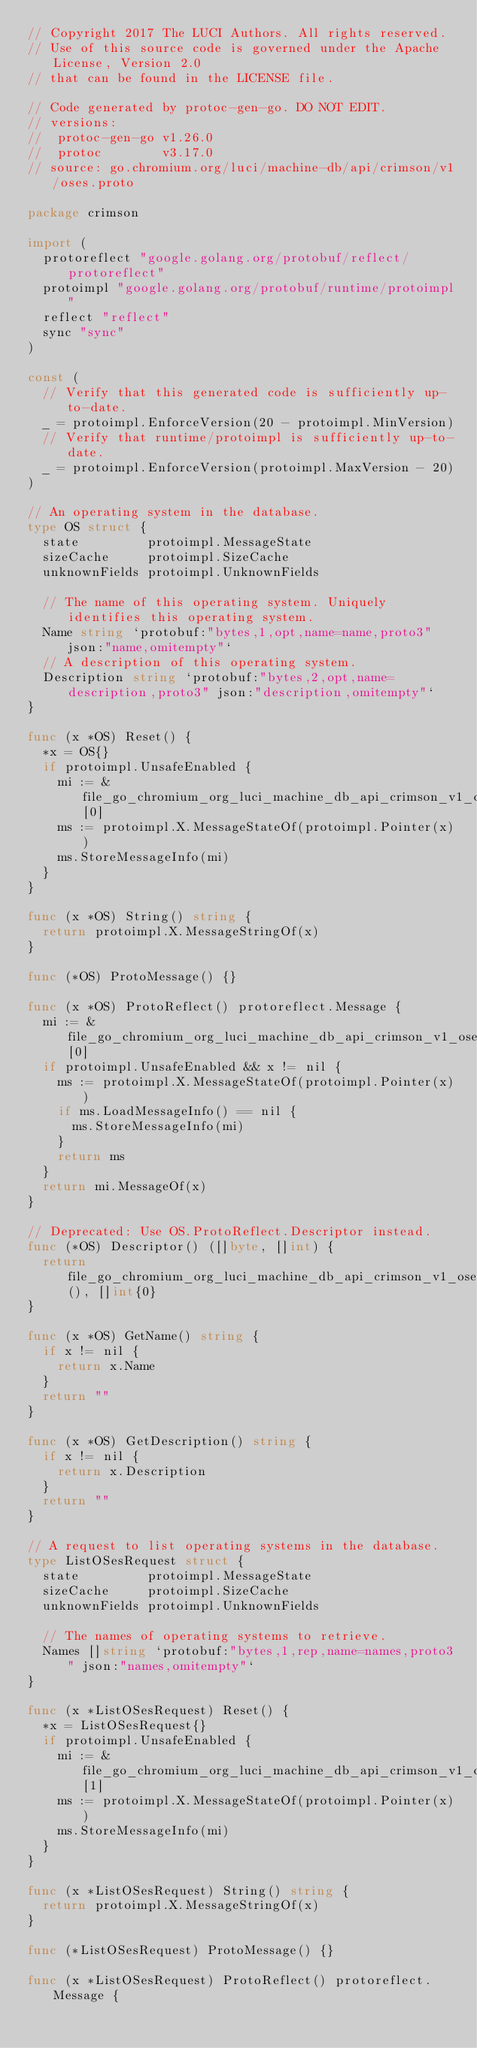Convert code to text. <code><loc_0><loc_0><loc_500><loc_500><_Go_>// Copyright 2017 The LUCI Authors. All rights reserved.
// Use of this source code is governed under the Apache License, Version 2.0
// that can be found in the LICENSE file.

// Code generated by protoc-gen-go. DO NOT EDIT.
// versions:
// 	protoc-gen-go v1.26.0
// 	protoc        v3.17.0
// source: go.chromium.org/luci/machine-db/api/crimson/v1/oses.proto

package crimson

import (
	protoreflect "google.golang.org/protobuf/reflect/protoreflect"
	protoimpl "google.golang.org/protobuf/runtime/protoimpl"
	reflect "reflect"
	sync "sync"
)

const (
	// Verify that this generated code is sufficiently up-to-date.
	_ = protoimpl.EnforceVersion(20 - protoimpl.MinVersion)
	// Verify that runtime/protoimpl is sufficiently up-to-date.
	_ = protoimpl.EnforceVersion(protoimpl.MaxVersion - 20)
)

// An operating system in the database.
type OS struct {
	state         protoimpl.MessageState
	sizeCache     protoimpl.SizeCache
	unknownFields protoimpl.UnknownFields

	// The name of this operating system. Uniquely identifies this operating system.
	Name string `protobuf:"bytes,1,opt,name=name,proto3" json:"name,omitempty"`
	// A description of this operating system.
	Description string `protobuf:"bytes,2,opt,name=description,proto3" json:"description,omitempty"`
}

func (x *OS) Reset() {
	*x = OS{}
	if protoimpl.UnsafeEnabled {
		mi := &file_go_chromium_org_luci_machine_db_api_crimson_v1_oses_proto_msgTypes[0]
		ms := protoimpl.X.MessageStateOf(protoimpl.Pointer(x))
		ms.StoreMessageInfo(mi)
	}
}

func (x *OS) String() string {
	return protoimpl.X.MessageStringOf(x)
}

func (*OS) ProtoMessage() {}

func (x *OS) ProtoReflect() protoreflect.Message {
	mi := &file_go_chromium_org_luci_machine_db_api_crimson_v1_oses_proto_msgTypes[0]
	if protoimpl.UnsafeEnabled && x != nil {
		ms := protoimpl.X.MessageStateOf(protoimpl.Pointer(x))
		if ms.LoadMessageInfo() == nil {
			ms.StoreMessageInfo(mi)
		}
		return ms
	}
	return mi.MessageOf(x)
}

// Deprecated: Use OS.ProtoReflect.Descriptor instead.
func (*OS) Descriptor() ([]byte, []int) {
	return file_go_chromium_org_luci_machine_db_api_crimson_v1_oses_proto_rawDescGZIP(), []int{0}
}

func (x *OS) GetName() string {
	if x != nil {
		return x.Name
	}
	return ""
}

func (x *OS) GetDescription() string {
	if x != nil {
		return x.Description
	}
	return ""
}

// A request to list operating systems in the database.
type ListOSesRequest struct {
	state         protoimpl.MessageState
	sizeCache     protoimpl.SizeCache
	unknownFields protoimpl.UnknownFields

	// The names of operating systems to retrieve.
	Names []string `protobuf:"bytes,1,rep,name=names,proto3" json:"names,omitempty"`
}

func (x *ListOSesRequest) Reset() {
	*x = ListOSesRequest{}
	if protoimpl.UnsafeEnabled {
		mi := &file_go_chromium_org_luci_machine_db_api_crimson_v1_oses_proto_msgTypes[1]
		ms := protoimpl.X.MessageStateOf(protoimpl.Pointer(x))
		ms.StoreMessageInfo(mi)
	}
}

func (x *ListOSesRequest) String() string {
	return protoimpl.X.MessageStringOf(x)
}

func (*ListOSesRequest) ProtoMessage() {}

func (x *ListOSesRequest) ProtoReflect() protoreflect.Message {</code> 